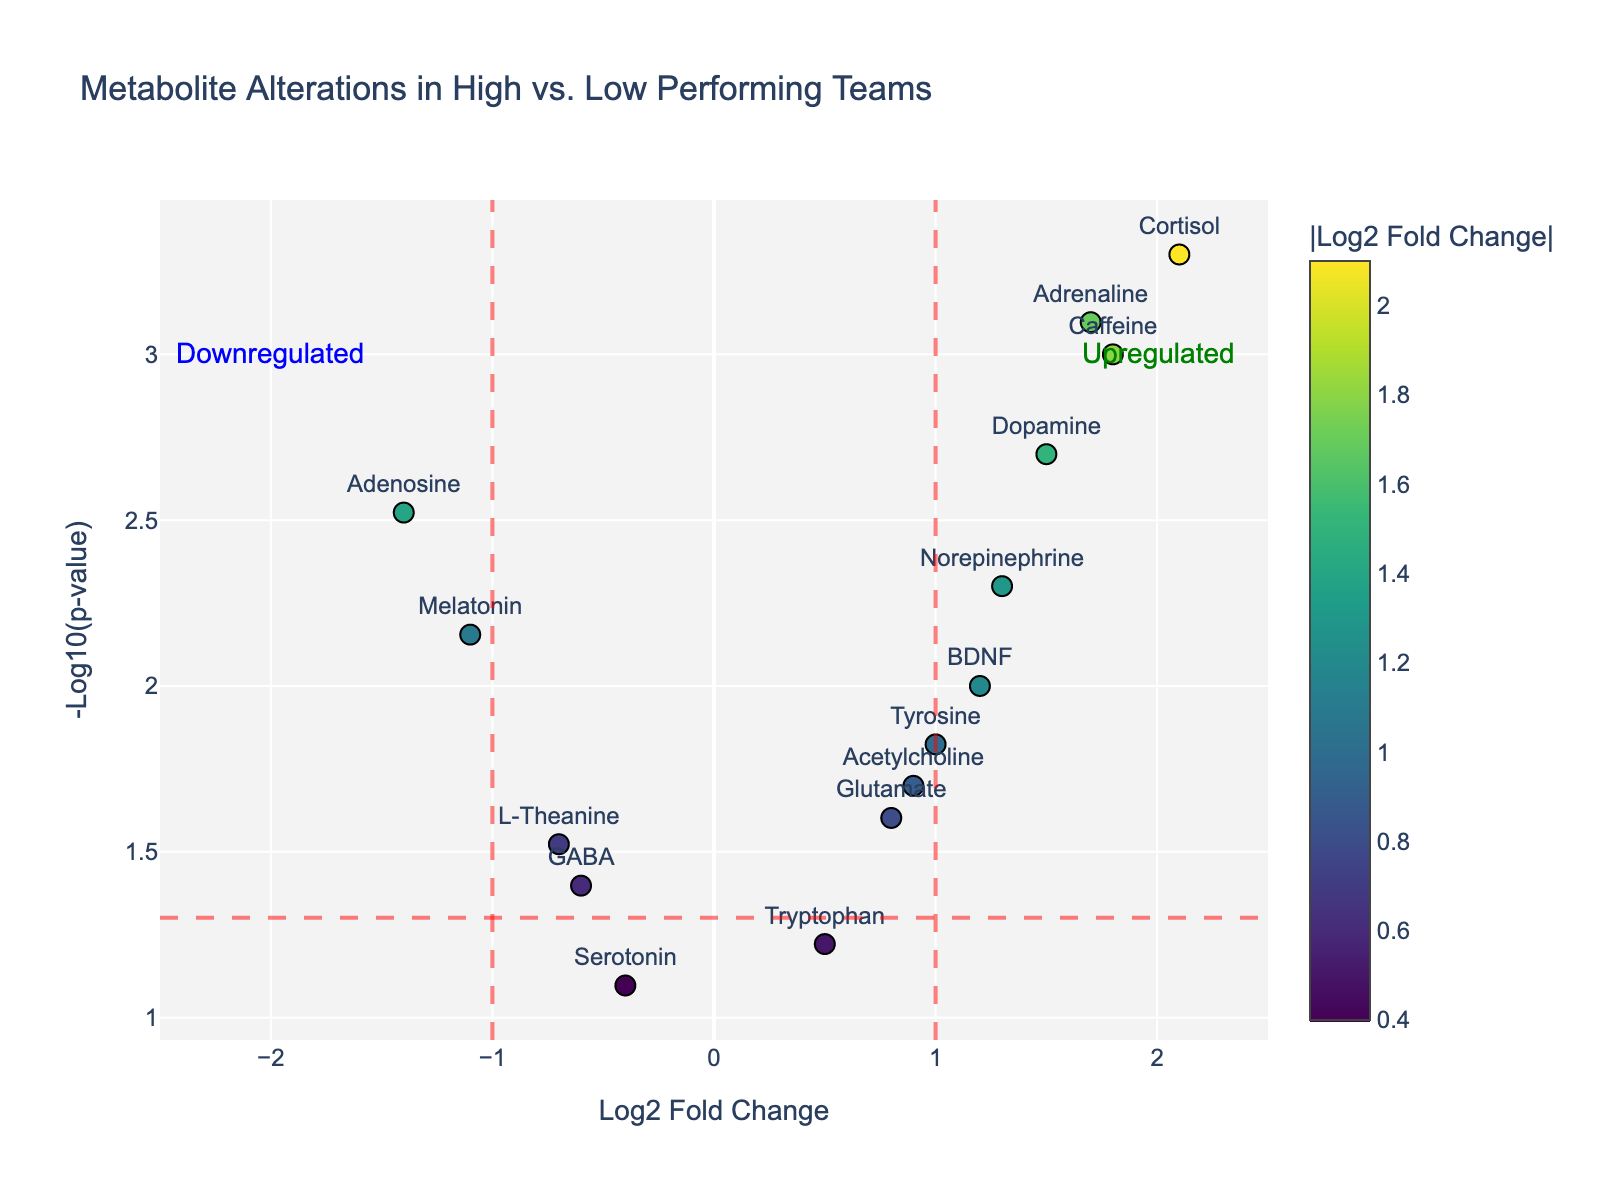What does the title of the figure indicate? The title of the figure provides an overall description of the content it depicts, indicating that the plot shows metabolite alterations in high vs. low performing teams.
Answer: Metabolite Alterations in High vs. Low Performing Teams How many metabolites are shown in the plot? The number of metabolites corresponds to the number of data points in the plot, as each metabolite is represented by a marker with text labels. By counting the labels, we get the number of metabolites.
Answer: 15 Which metabolite has the highest log2 fold change? To find the metabolite with the highest log2 fold change, we look for the marker furthest to the right on the x-axis.
Answer: Cortisol Which metabolite has the lowest p-value? To identify the metabolite with the lowest p-value, we look for the marker positioned highest on the y-axis, as the y-axis represents -Log10(p-value).
Answer: Cortisol Which metabolite shows a significant downregulation? Significant downregulation can be identified by a marker that lies to the left of the red vertical line on the x-axis at -1 and above the red horizontal line on the y-axis.
Answer: Adenosine How does Melatonin's log2 fold change compare to Serotonin's? Melatonin's marker is located further to the left and higher on the plot compared to Serotonin's marker, indicating Melatonin has a more negative log2 fold change than Serotonin.
Answer: Melatonin has a more negative log2 fold change than Serotonin How many metabolites have a p-value less than 0.01? To find this, count the number of markers that lie above the horizontal red line indicating the threshold for p-value (since -Log10(0.01) = 2).
Answer: 5 What's the difference in the log2 fold change between Dopamine and L-Theanine? Calculate the difference between the log2 fold change values of Dopamine and L-Theanine by subtracting L-Theanine's value from Dopamine's value.
Answer: 2.2 